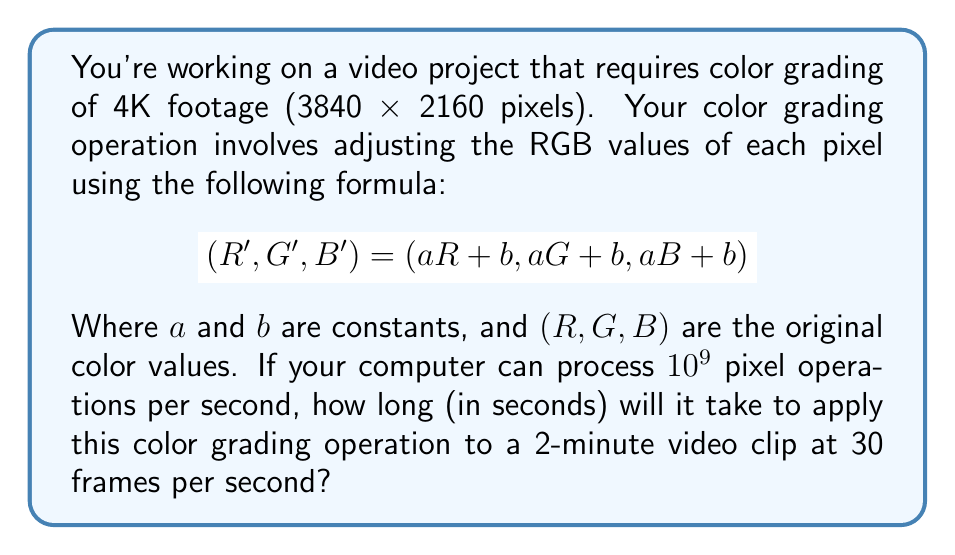Give your solution to this math problem. Let's break this down step by step:

1) First, calculate the number of pixels in a single 4K frame:
   $3840 \times 2160 = 8,294,400$ pixels

2) Calculate the number of frames in a 2-minute video at 30 fps:
   $2 \text{ minutes} \times 60 \text{ seconds/minute} \times 30 \text{ frames/second} = 3600$ frames

3) Calculate the total number of pixels to process:
   $8,294,400 \text{ pixels/frame} \times 3600 \text{ frames} = 29,859,840,000$ pixels

4) For each pixel, we need to perform 3 operations (one for each color channel):
   $29,859,840,000 \times 3 = 89,579,520,000$ operations

5) Given the computer's processing speed of $10^9$ operations per second:
   $\text{Time} = \frac{\text{Total operations}}{\text{Operations per second}}$
   $= \frac{89,579,520,000}{10^9} = 89.57952$ seconds

Therefore, it will take approximately 89.58 seconds to apply the color grading operation to the entire video clip.
Answer: 89.58 seconds 